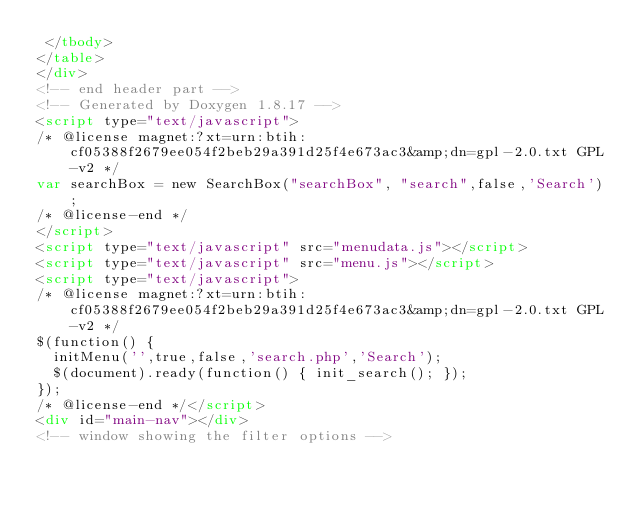<code> <loc_0><loc_0><loc_500><loc_500><_HTML_> </tbody>
</table>
</div>
<!-- end header part -->
<!-- Generated by Doxygen 1.8.17 -->
<script type="text/javascript">
/* @license magnet:?xt=urn:btih:cf05388f2679ee054f2beb29a391d25f4e673ac3&amp;dn=gpl-2.0.txt GPL-v2 */
var searchBox = new SearchBox("searchBox", "search",false,'Search');
/* @license-end */
</script>
<script type="text/javascript" src="menudata.js"></script>
<script type="text/javascript" src="menu.js"></script>
<script type="text/javascript">
/* @license magnet:?xt=urn:btih:cf05388f2679ee054f2beb29a391d25f4e673ac3&amp;dn=gpl-2.0.txt GPL-v2 */
$(function() {
  initMenu('',true,false,'search.php','Search');
  $(document).ready(function() { init_search(); });
});
/* @license-end */</script>
<div id="main-nav"></div>
<!-- window showing the filter options --></code> 